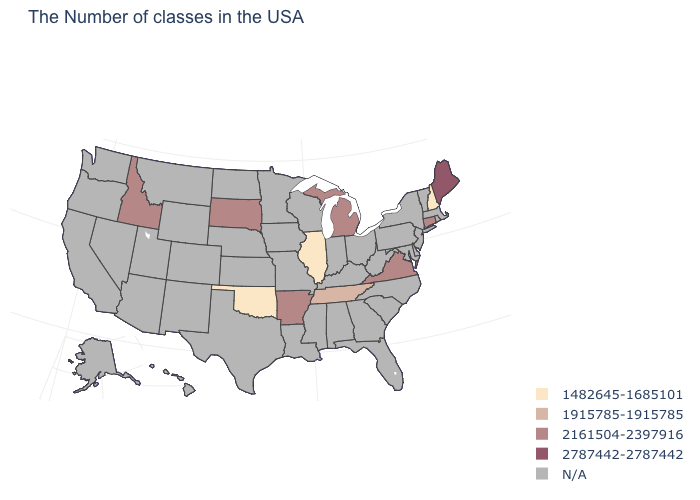Does the map have missing data?
Quick response, please. Yes. What is the value of New Hampshire?
Concise answer only. 1482645-1685101. What is the value of Maryland?
Be succinct. N/A. What is the lowest value in states that border Massachusetts?
Keep it brief. 1482645-1685101. Which states have the highest value in the USA?
Concise answer only. Maine. How many symbols are there in the legend?
Answer briefly. 5. Name the states that have a value in the range 1915785-1915785?
Be succinct. Tennessee. What is the value of Hawaii?
Be succinct. N/A. What is the value of South Carolina?
Keep it brief. N/A. What is the value of Utah?
Concise answer only. N/A. What is the value of Ohio?
Short answer required. N/A. What is the lowest value in the USA?
Short answer required. 1482645-1685101. What is the highest value in the USA?
Give a very brief answer. 2787442-2787442. 